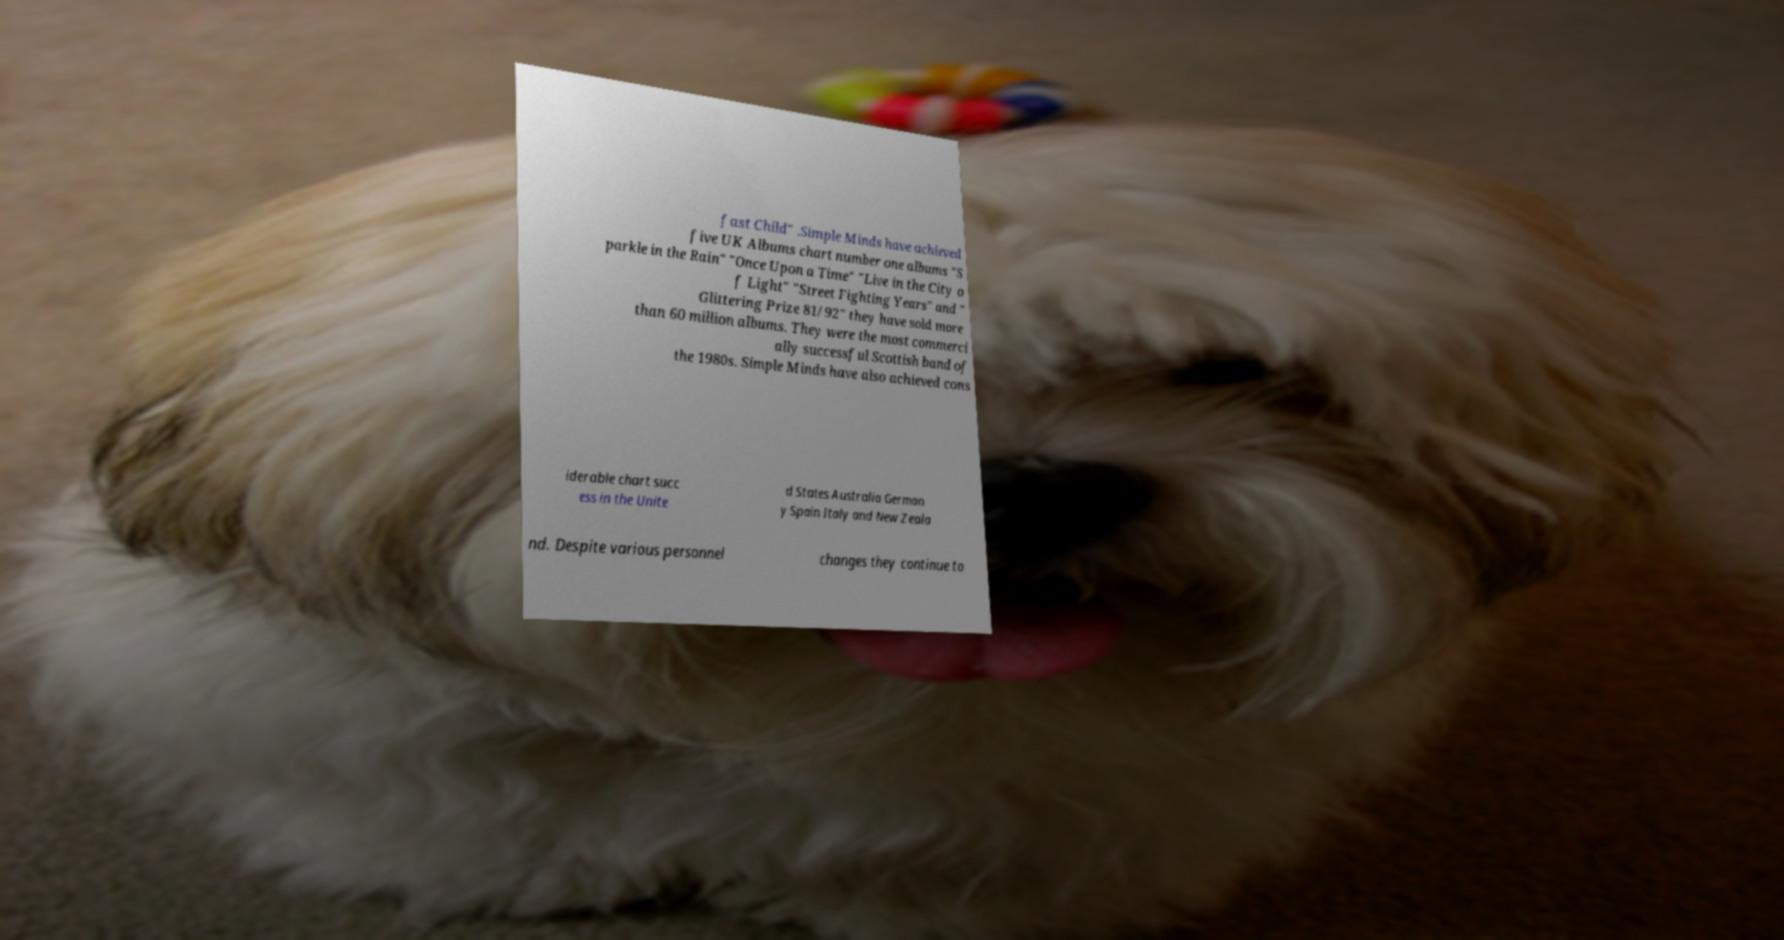For documentation purposes, I need the text within this image transcribed. Could you provide that? fast Child" .Simple Minds have achieved five UK Albums chart number one albums "S parkle in the Rain" "Once Upon a Time" "Live in the City o f Light" "Street Fighting Years" and " Glittering Prize 81/92" they have sold more than 60 million albums. They were the most commerci ally successful Scottish band of the 1980s. Simple Minds have also achieved cons iderable chart succ ess in the Unite d States Australia German y Spain Italy and New Zeala nd. Despite various personnel changes they continue to 